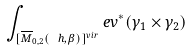Convert formula to latex. <formula><loc_0><loc_0><loc_500><loc_500>\int _ { [ \overline { M } _ { 0 , 2 } ( \ h , \beta ) ] ^ { v i r } } e v ^ { * } ( \gamma _ { 1 } \times \gamma _ { 2 } )</formula> 